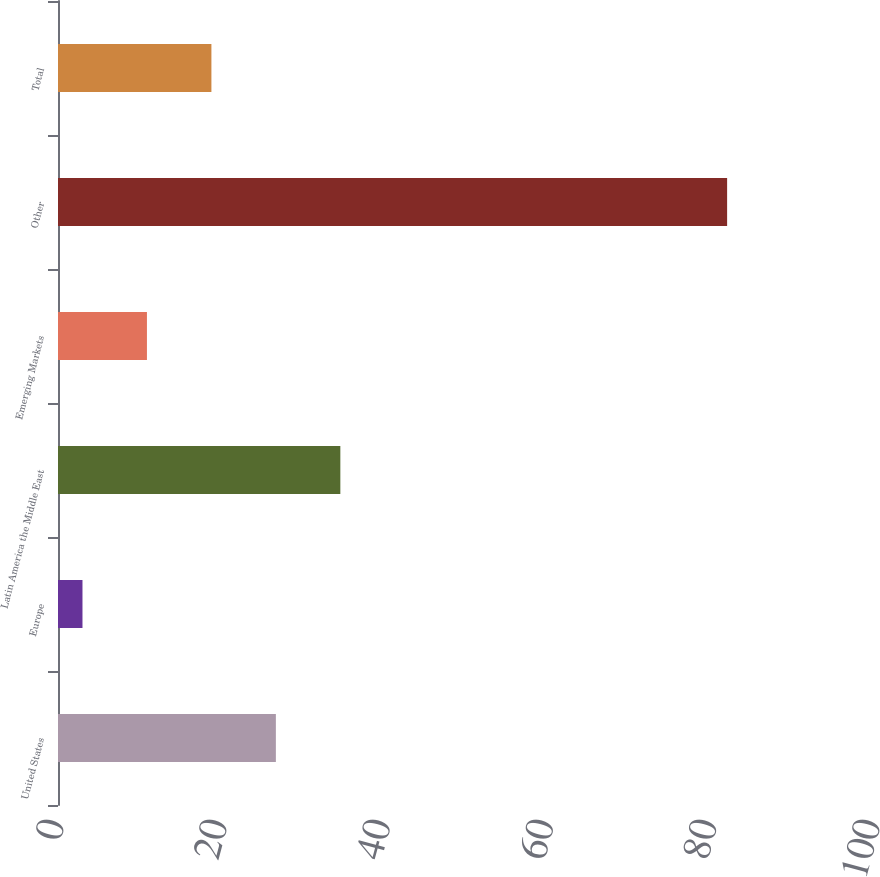<chart> <loc_0><loc_0><loc_500><loc_500><bar_chart><fcel>United States<fcel>Europe<fcel>Latin America the Middle East<fcel>Emerging Markets<fcel>Other<fcel>Total<nl><fcel>26.7<fcel>3<fcel>34.6<fcel>10.9<fcel>82<fcel>18.8<nl></chart> 